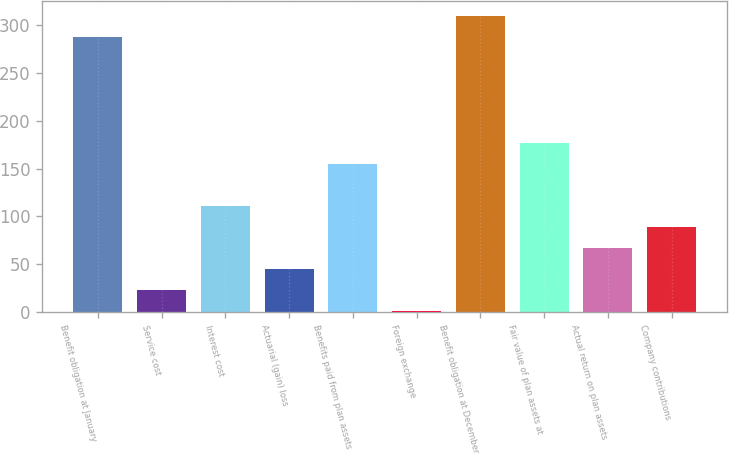<chart> <loc_0><loc_0><loc_500><loc_500><bar_chart><fcel>Benefit obligation at January<fcel>Service cost<fcel>Interest cost<fcel>Actuarial (gain) loss<fcel>Benefits paid from plan assets<fcel>Foreign exchange<fcel>Benefit obligation at December<fcel>Fair value of plan assets at<fcel>Actual return on plan assets<fcel>Company contributions<nl><fcel>287<fcel>23<fcel>111<fcel>45<fcel>155<fcel>1<fcel>309<fcel>177<fcel>67<fcel>89<nl></chart> 